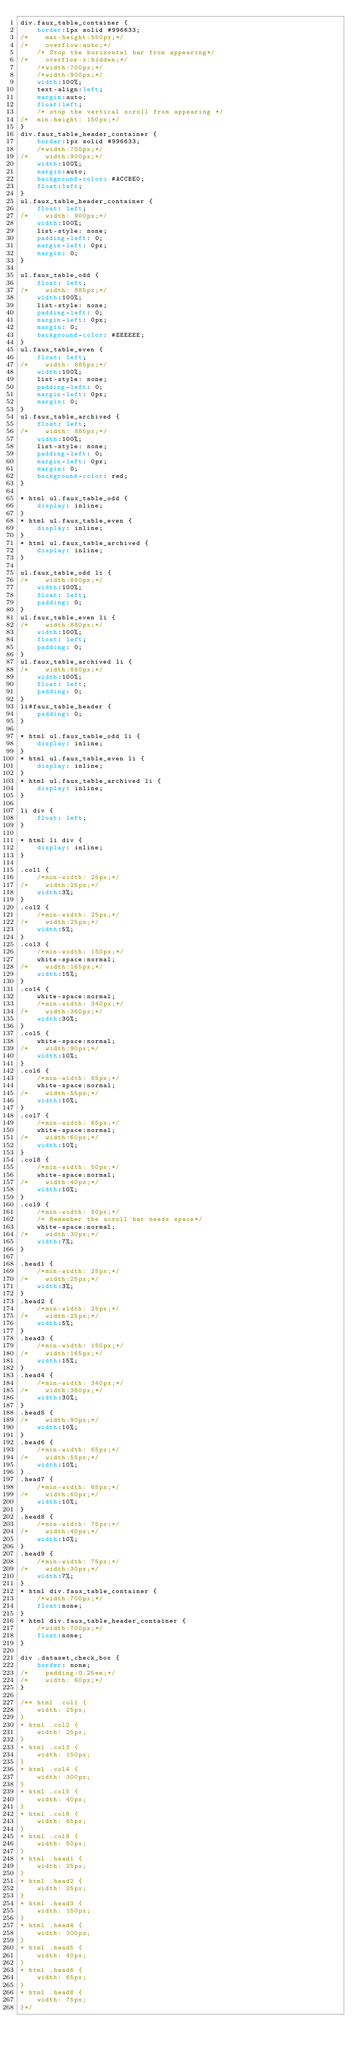Convert code to text. <code><loc_0><loc_0><loc_500><loc_500><_CSS_>div.faux_table_container {
    border:1px solid #996633;
/*    max-height:550px;*/
/*    overflow:auto;*/
    /* Stop the horizontal bar from appearing*/
/*    overflow-x:hidden;*/
    /*width:700px;*/
    /*width:900px;*/
	width:100%;
    text-align:left;
    margin:auto;
    float:left;
	/* stop the vertical scroll from appearing */
/*	min-height: 150px;*/
}
div.faux_table_header_container {
    border:1px solid #996633;
    /*width:700px;*/
/*    width:900px;*/
	width:100%;
    margin:auto;
    background-color: #ACCBE0;
    float:left;
}
ul.faux_table_header_container {
    float: left;
/*    width: 900px;*/
	width:100%;
    list-style: none;
    padding-left: 0;
    margin-left: 0px;
    margin: 0;
}

ul.faux_table_odd {
    float: left;
/*    width: 885px;*/
	width:100%;
    list-style: none;
    padding-left: 0;
    margin-left: 0px;
    margin: 0;
    background-color: #EEEEEE;
}
ul.faux_table_even {
    float: left;
/*    width: 885px;*/
	width:100%;
    list-style: none;
    padding-left: 0;
    margin-left: 0px;
    margin: 0;
}
ul.faux_table_archived {
	float: left;
/*    width: 885px;*/
	width:100%;
    list-style: none;
    padding-left: 0;
    margin-left: 0px;
    margin: 0;
    background-color: red;
}

* html ul.faux_table_odd {
    display: inline;
}
* html ul.faux_table_even {
    display: inline;
}
* html ul.faux_table_archived {
    display: inline;
}

ul.faux_table_odd li {
/*    width:880px;*/
	width:100%;
    float: left;
	padding: 0;
}
ul.faux_table_even li {
/*    width:880px;*/
	width:100%;
    float: left;
	padding: 0;
}
ul.faux_table_archived li {
/*    width:880px;*/
	width:100%;
    float: left;
	padding: 0;
}
li#faux_table_header {
	padding: 0;
}

* html ul.faux_table_odd li {
    display: inline;
}
* html ul.faux_table_even li {
    display: inline;
}
* html ul.faux_table_archived li {
    display: inline;
}

li div {
    float: left;
}

* html li div {
    display: inline;
}

.col1 {
    /*min-width: 25px;*/
/*    width:25px;*/
	width:3%;
}
.col2 {
    /*min-width: 25px;*/
/*    width:25px;*/
	width:5%;
}
.col3 {
    /*min-width: 150px;*/
	white-space:normal;
/*    width:165px;*/
	width:15%;
}
.col4 {
    white-space:normal;
    /*min-width: 340px;*/
/*    width:360px;*/
	width:30%;
}
.col5 {
    white-space:normal;
/*    width:90px;*/
	width:10%;
}
.col6 {
    /*min-width: 65px;*/
	white-space:normal;
/*    width:55px;*/
	width:10%;
}
.col7 {
    /*min-width: 65px;*/
	white-space:normal;
/*    width:60px;*/
	width:10%;
}
.col8 {
    /*min-width: 50px;*/
	white-space:normal;
/*    width:40px;*/
	width:10%;
}
.col9 {
    /*min-width: 50px;*/
    /* Remember the scroll bar needs space*/
	white-space:normal;
/*    width:30px;*/
	width:7%;
}

.head1 {
    /*min-width: 25px;*/
/*    width:25px;*/
	width:3%;
}
.head2 {
    /*min-width: 25px;*/
/*    width:25px;*/
	width:5%;
}
.head3 {
    /*min-width: 150px;*/
/*    width:165px;*/
	width:15%;
}
.head4 {
    /*min-width: 340px;*/
/*    width:360px;*/
	width:30%;
}
.head5 {
/*    width:90px;*/
	width:10%;
}
.head6 {
    /*min-width: 65px;*/
/*    width:55px;*/
	width:10%;
}
.head7 {
    /*min-width: 65px;*/
/*    width:60px;*/
	width:10%;
}
.head8 {
    /*min-width: 75px;*/
/*    width:40px;*/
	width:10%;
}
.head9 {
    /*min-width: 75px;*/
/*    width:30px;*/
	width:7%;
}
* html div.faux_table_container {
    /*width:700px;*/
    float:none;
}
* html div.faux_table_header_container {
    /*width:700px;*/
    float:none;
}

div .dataset_check_box {
    border: none;
/*    padding:0.25em;*/
/*    width: 60px;*/
}

/** html .col1 {
    width: 25px;
}
* html .col2 {
    width: 25px;
}
* html .col3 {
    width: 150px;
}
* html .col4 {
    width: 300px;
}
* html .col5 {
    width: 40px;
}
* html .col6 {
    width: 65px;
}
* html .col8 {
    width: 50px;
}
* html .head1 {
    width: 25px;
}
* html .head2 {
    width: 25px;
}
* html .head3 {
    width: 150px;
}
* html .head4 {
    width: 300px;
}
* html .head5 {
    width: 40px;
}
* html .head6 {
    width: 65px;
}
* html .head8 {
    width: 75px;
}*/</code> 